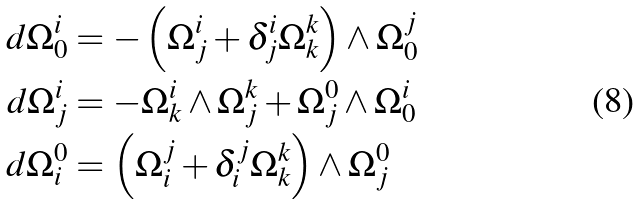<formula> <loc_0><loc_0><loc_500><loc_500>d \Omega ^ { i } _ { 0 } & = - \left ( \Omega ^ { i } _ { j } + \delta ^ { i } _ { j } \Omega ^ { k } _ { k } \right ) \wedge \Omega ^ { j } _ { 0 } \\ d \Omega ^ { i } _ { j } & = - \Omega ^ { i } _ { k } \wedge \Omega ^ { k } _ { j } + \Omega ^ { 0 } _ { j } \wedge \Omega ^ { i } _ { 0 } \\ d \Omega ^ { 0 } _ { i } & = \left ( \Omega ^ { j } _ { i } + \delta ^ { j } _ { i } \Omega ^ { k } _ { k } \right ) \wedge \Omega ^ { 0 } _ { j }</formula> 